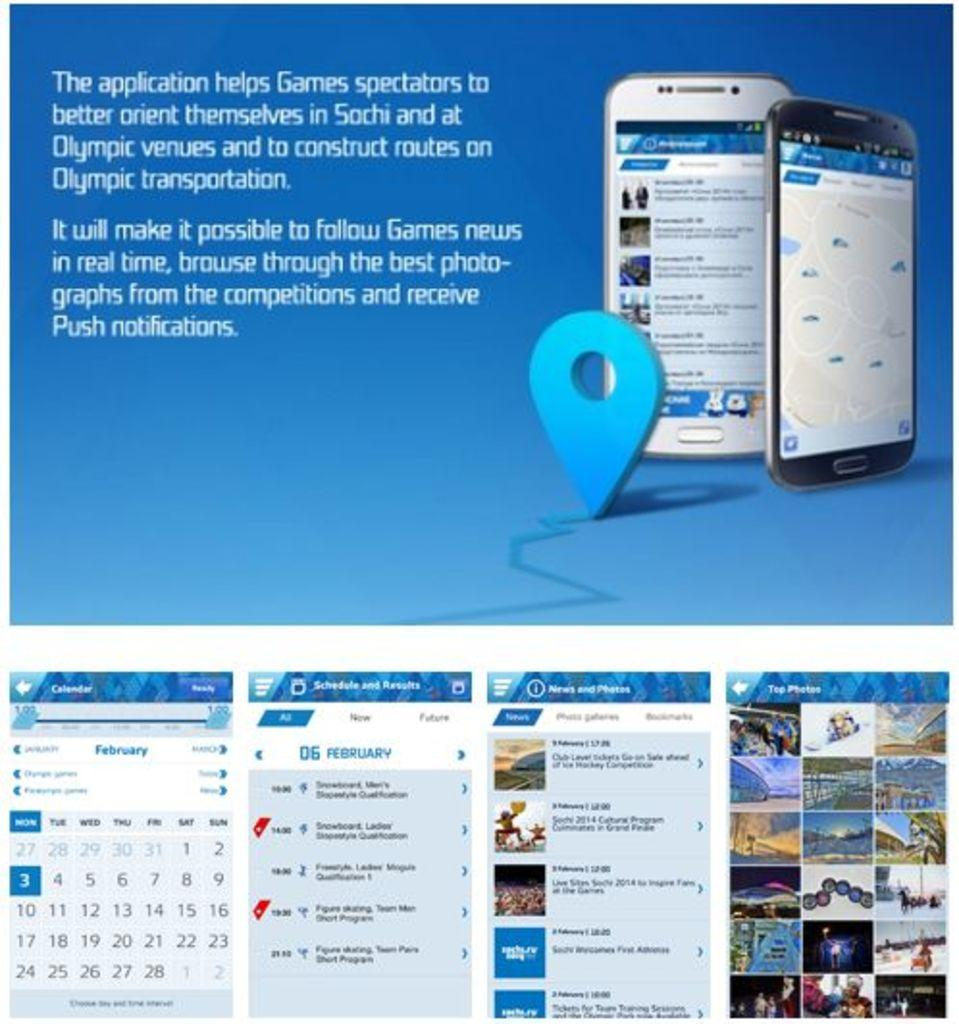Provide a one-sentence caption for the provided image. Advertisement about an app to help spectators navigate in Sochi during the Olympics with the month of February on the bottom left. 